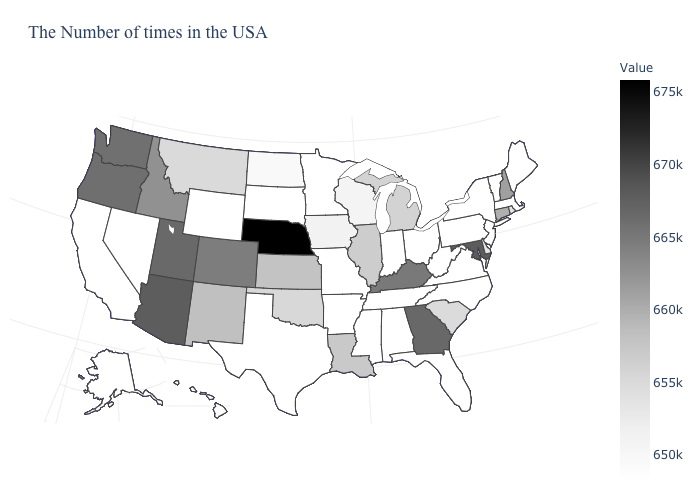Which states have the highest value in the USA?
Answer briefly. Nebraska. Among the states that border Arizona , does Nevada have the lowest value?
Answer briefly. Yes. Which states have the lowest value in the USA?
Keep it brief. Maine, Massachusetts, Vermont, New York, New Jersey, Pennsylvania, Virginia, North Carolina, West Virginia, Ohio, Florida, Indiana, Alabama, Tennessee, Mississippi, Missouri, Arkansas, Minnesota, Texas, South Dakota, Wyoming, Nevada, California, Alaska, Hawaii. Does South Carolina have a higher value than Nebraska?
Concise answer only. No. Among the states that border New York , does Massachusetts have the lowest value?
Concise answer only. Yes. Does California have the lowest value in the USA?
Give a very brief answer. Yes. Does Texas have the highest value in the USA?
Concise answer only. No. Does Nebraska have the highest value in the USA?
Short answer required. Yes. 